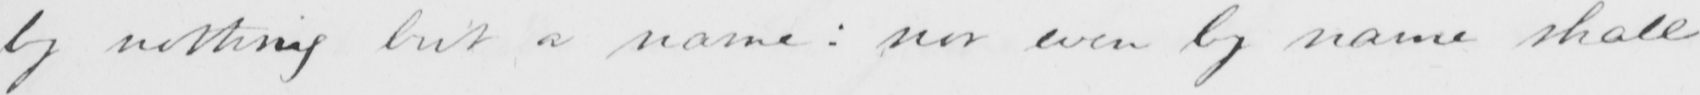What is written in this line of handwriting? by nothing but a name :  nor even by name shall 